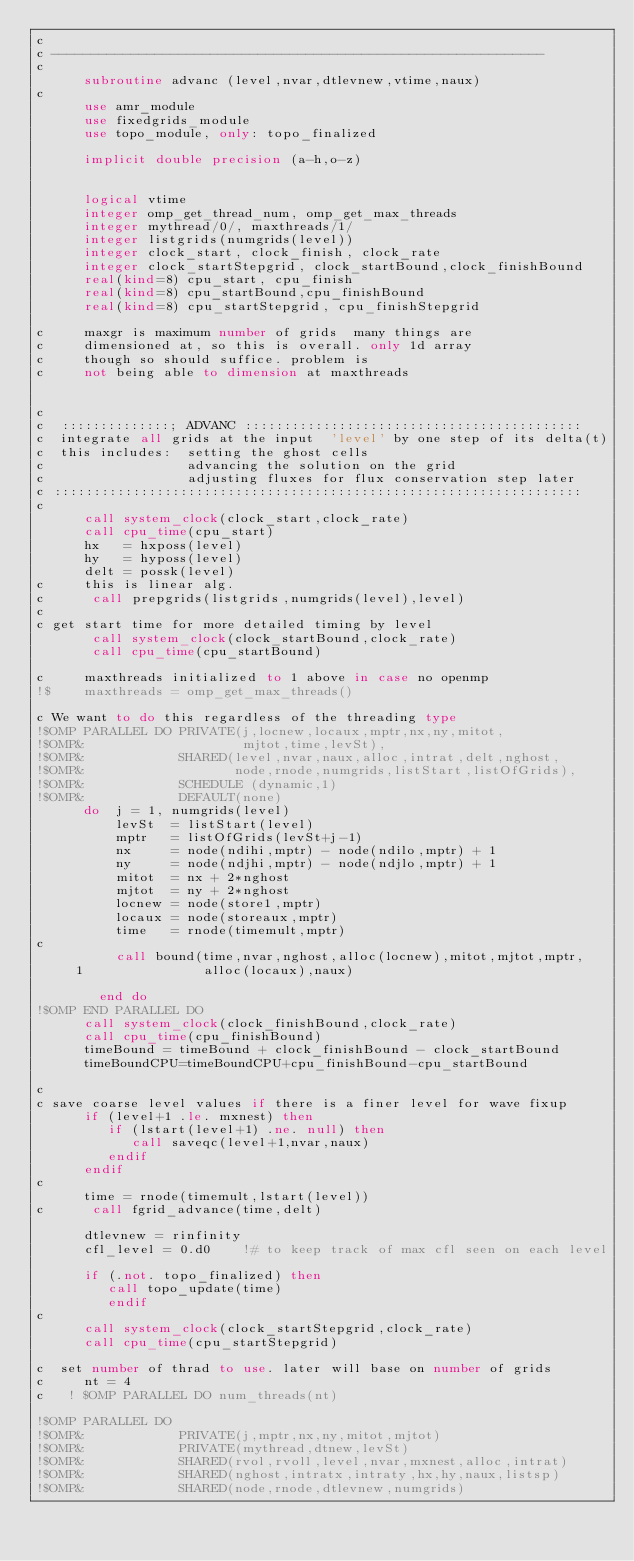<code> <loc_0><loc_0><loc_500><loc_500><_FORTRAN_>c
c --------------------------------------------------------------
c
      subroutine advanc (level,nvar,dtlevnew,vtime,naux)
c
      use amr_module
      use fixedgrids_module
      use topo_module, only: topo_finalized

      implicit double precision (a-h,o-z)


      logical vtime
      integer omp_get_thread_num, omp_get_max_threads
      integer mythread/0/, maxthreads/1/
      integer listgrids(numgrids(level))
      integer clock_start, clock_finish, clock_rate
      integer clock_startStepgrid, clock_startBound,clock_finishBound
      real(kind=8) cpu_start, cpu_finish
      real(kind=8) cpu_startBound,cpu_finishBound
      real(kind=8) cpu_startStepgrid, cpu_finishStepgrid

c     maxgr is maximum number of grids  many things are
c     dimensioned at, so this is overall. only 1d array
c     though so should suffice. problem is
c     not being able to dimension at maxthreads


c
c  ::::::::::::::; ADVANC :::::::::::::::::::::::::::::::::::::::::::
c  integrate all grids at the input  'level' by one step of its delta(t)
c  this includes:  setting the ghost cells 
c                  advancing the solution on the grid
c                  adjusting fluxes for flux conservation step later
c :::::::::::::::::::::::::::::::::::::::::::::::::::::::::::::::::::
c
      call system_clock(clock_start,clock_rate)
      call cpu_time(cpu_start)
      hx   = hxposs(level)
      hy   = hyposs(level)
      delt = possk(level)
c     this is linear alg.
c      call prepgrids(listgrids,numgrids(level),level)
c
c get start time for more detailed timing by level
       call system_clock(clock_startBound,clock_rate)
       call cpu_time(cpu_startBound)

c     maxthreads initialized to 1 above in case no openmp
!$    maxthreads = omp_get_max_threads()

c We want to do this regardless of the threading type
!$OMP PARALLEL DO PRIVATE(j,locnew,locaux,mptr,nx,ny,mitot,
!$OMP&                    mjtot,time,levSt),
!$OMP&            SHARED(level,nvar,naux,alloc,intrat,delt,nghost,
!$OMP&                   node,rnode,numgrids,listStart,listOfGrids),
!$OMP&            SCHEDULE (dynamic,1)
!$OMP&            DEFAULT(none)
      do  j = 1, numgrids(level)
          levSt  = listStart(level)
          mptr   = listOfGrids(levSt+j-1)
          nx     = node(ndihi,mptr) - node(ndilo,mptr) + 1
          ny     = node(ndjhi,mptr) - node(ndjlo,mptr) + 1
          mitot  = nx + 2*nghost
          mjtot  = ny + 2*nghost
          locnew = node(store1,mptr)
          locaux = node(storeaux,mptr)
          time   = rnode(timemult,mptr)
c
          call bound(time,nvar,nghost,alloc(locnew),mitot,mjtot,mptr,
     1               alloc(locaux),naux)

        end do
!$OMP END PARALLEL DO
      call system_clock(clock_finishBound,clock_rate)
      call cpu_time(cpu_finishBound)
      timeBound = timeBound + clock_finishBound - clock_startBound
      timeBoundCPU=timeBoundCPU+cpu_finishBound-cpu_startBound

c
c save coarse level values if there is a finer level for wave fixup
      if (level+1 .le. mxnest) then
         if (lstart(level+1) .ne. null) then
            call saveqc(level+1,nvar,naux)
         endif
      endif
c
      time = rnode(timemult,lstart(level))
c      call fgrid_advance(time,delt)
      
      dtlevnew = rinfinity
      cfl_level = 0.d0    !# to keep track of max cfl seen on each level

      if (.not. topo_finalized) then
         call topo_update(time)
         endif
c 
      call system_clock(clock_startStepgrid,clock_rate)
      call cpu_time(cpu_startStepgrid)
        
c  set number of thrad to use. later will base on number of grids
c     nt = 4
c   ! $OMP PARALLEL DO num_threads(nt)

!$OMP PARALLEL DO 
!$OMP&            PRIVATE(j,mptr,nx,ny,mitot,mjtot)  
!$OMP&            PRIVATE(mythread,dtnew,levSt)
!$OMP&            SHARED(rvol,rvoll,level,nvar,mxnest,alloc,intrat)
!$OMP&            SHARED(nghost,intratx,intraty,hx,hy,naux,listsp)
!$OMP&            SHARED(node,rnode,dtlevnew,numgrids)</code> 